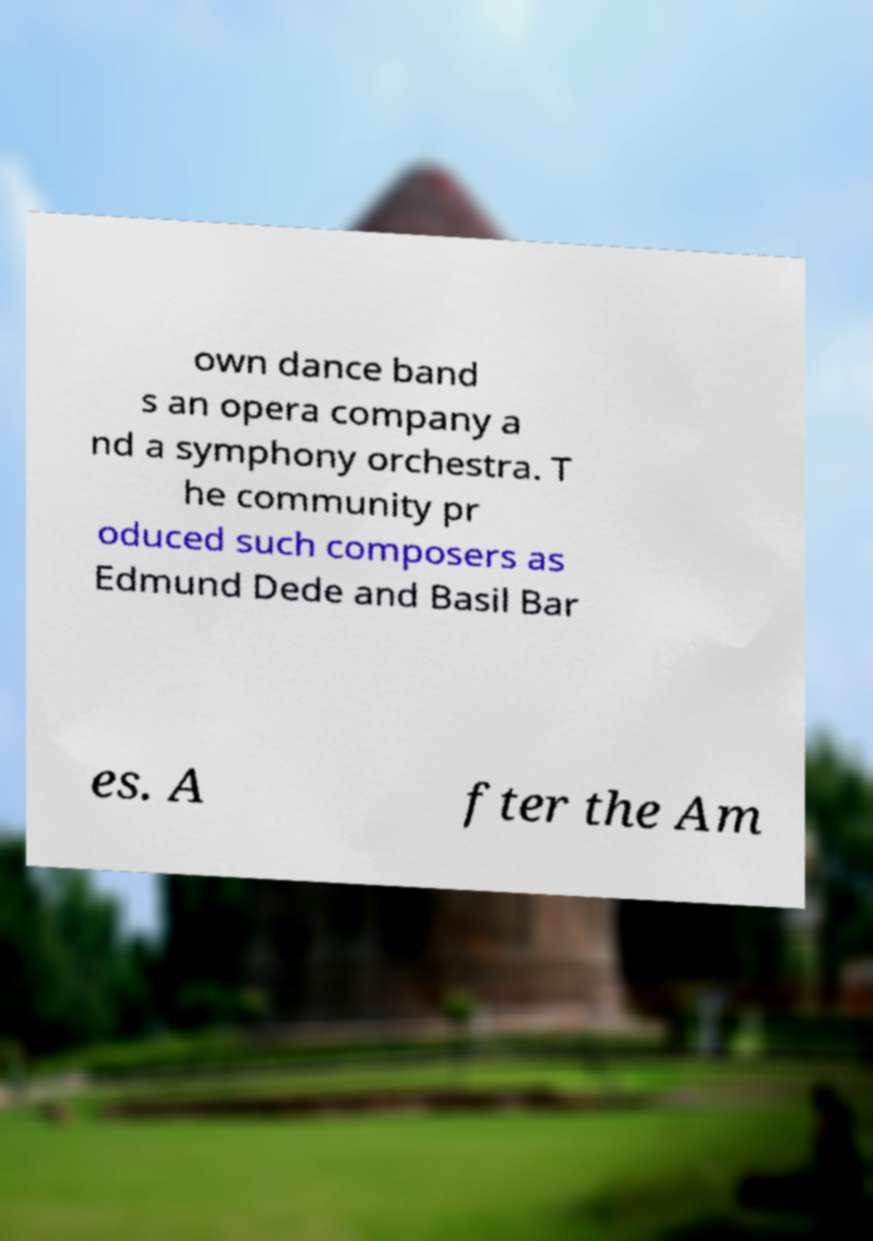For documentation purposes, I need the text within this image transcribed. Could you provide that? own dance band s an opera company a nd a symphony orchestra. T he community pr oduced such composers as Edmund Dede and Basil Bar es. A fter the Am 